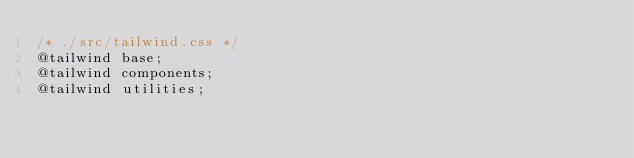<code> <loc_0><loc_0><loc_500><loc_500><_CSS_>/* ./src/tailwind.css */
@tailwind base;
@tailwind components;
@tailwind utilities;</code> 